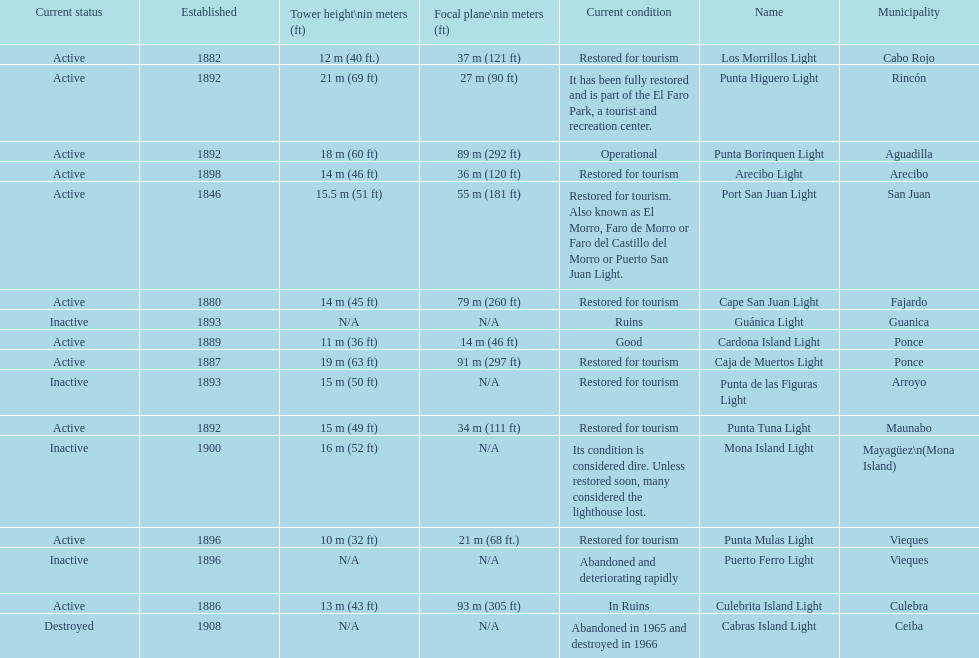Were any towers established before the year 1800? No. 